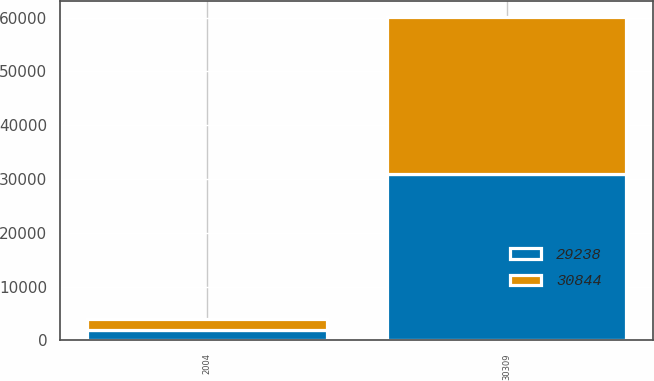Convert chart. <chart><loc_0><loc_0><loc_500><loc_500><stacked_bar_chart><ecel><fcel>2004<fcel>30309<nl><fcel>29238<fcel>2003<fcel>30844<nl><fcel>30844<fcel>2002<fcel>29238<nl></chart> 